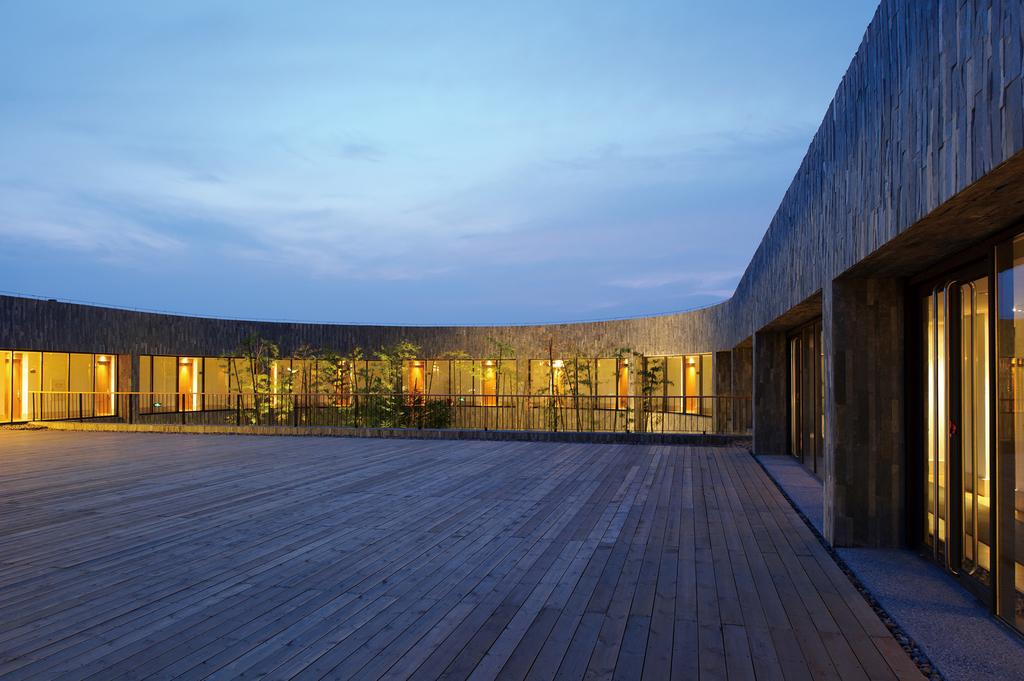What type of flooring is at the bottom of the image? There is a wooden floor at the bottom of the image. What can be seen in the background of the image? In the background of the image, there is a house, lights, plants, doors, and a fence. What is visible at the top of the image? The sky is visible at the top of the image. What type of skirt is the house wearing in the image? There is no skirt present in the image, as the house is a building and not a person. 